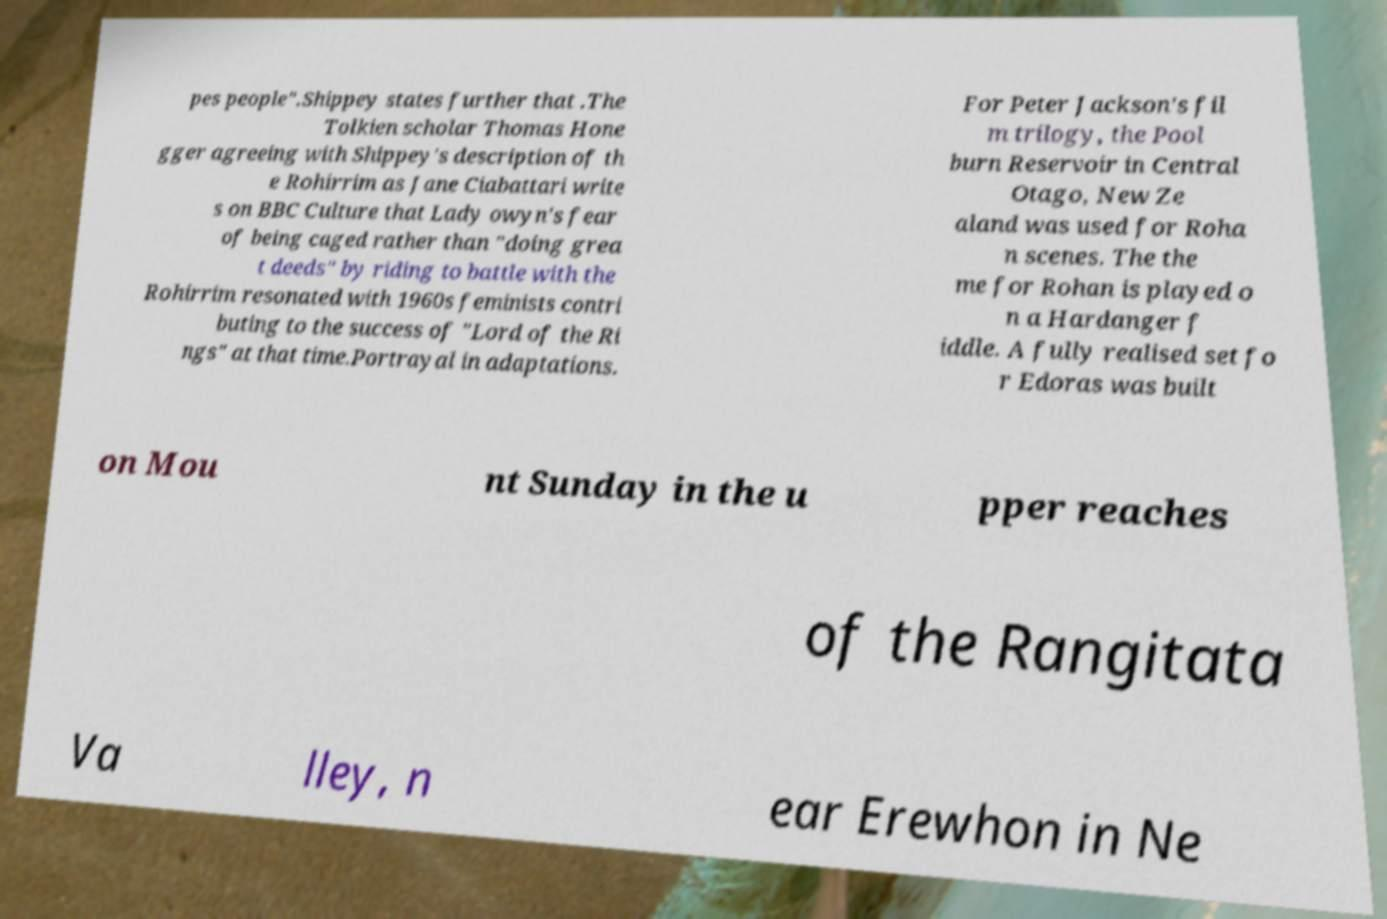Please identify and transcribe the text found in this image. pes people".Shippey states further that .The Tolkien scholar Thomas Hone gger agreeing with Shippey's description of th e Rohirrim as Jane Ciabattari write s on BBC Culture that Lady owyn's fear of being caged rather than "doing grea t deeds" by riding to battle with the Rohirrim resonated with 1960s feminists contri buting to the success of "Lord of the Ri ngs" at that time.Portrayal in adaptations. For Peter Jackson's fil m trilogy, the Pool burn Reservoir in Central Otago, New Ze aland was used for Roha n scenes. The the me for Rohan is played o n a Hardanger f iddle. A fully realised set fo r Edoras was built on Mou nt Sunday in the u pper reaches of the Rangitata Va lley, n ear Erewhon in Ne 